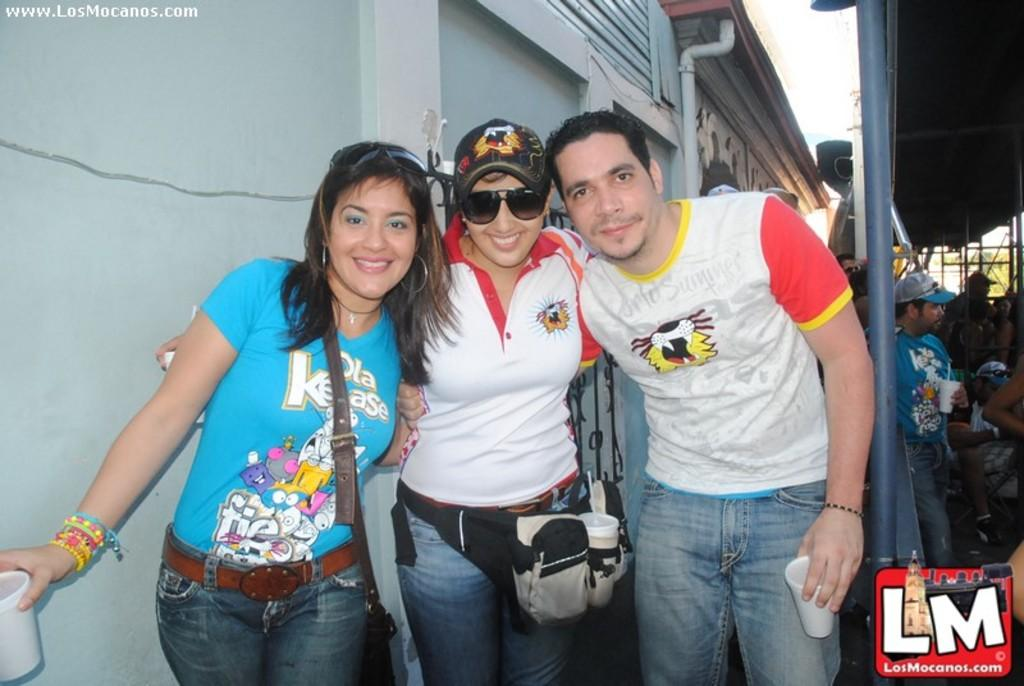How many people are present in the image? There are people in the image, but the exact number cannot be determined from the provided facts. What are the people holding in their hands? Some people are holding objects in their hands, but the specific objects cannot be identified from the provided facts. What type of structure is visible in the image? There is a shed in the image. What else can be seen in the image besides the people and the shed? There are objects in the image, but their nature cannot be determined from the provided facts. What type of tail can be seen on the person in the image? There is no tail visible on any person in the image. Where is the bedroom located in the image? There is no bedroom present in the image. 